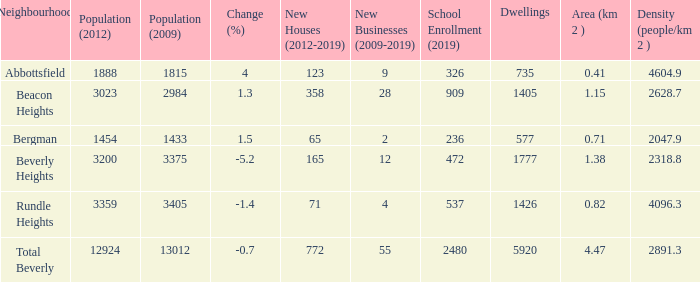What is the density of a zone that is 0.0. 